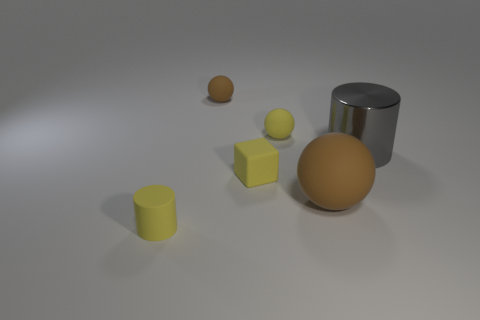Add 1 tiny rubber blocks. How many objects exist? 7 Subtract all cubes. How many objects are left? 5 Subtract all big matte cylinders. Subtract all yellow matte objects. How many objects are left? 3 Add 1 tiny yellow rubber cylinders. How many tiny yellow rubber cylinders are left? 2 Add 5 gray rubber things. How many gray rubber things exist? 5 Subtract 0 blue cylinders. How many objects are left? 6 